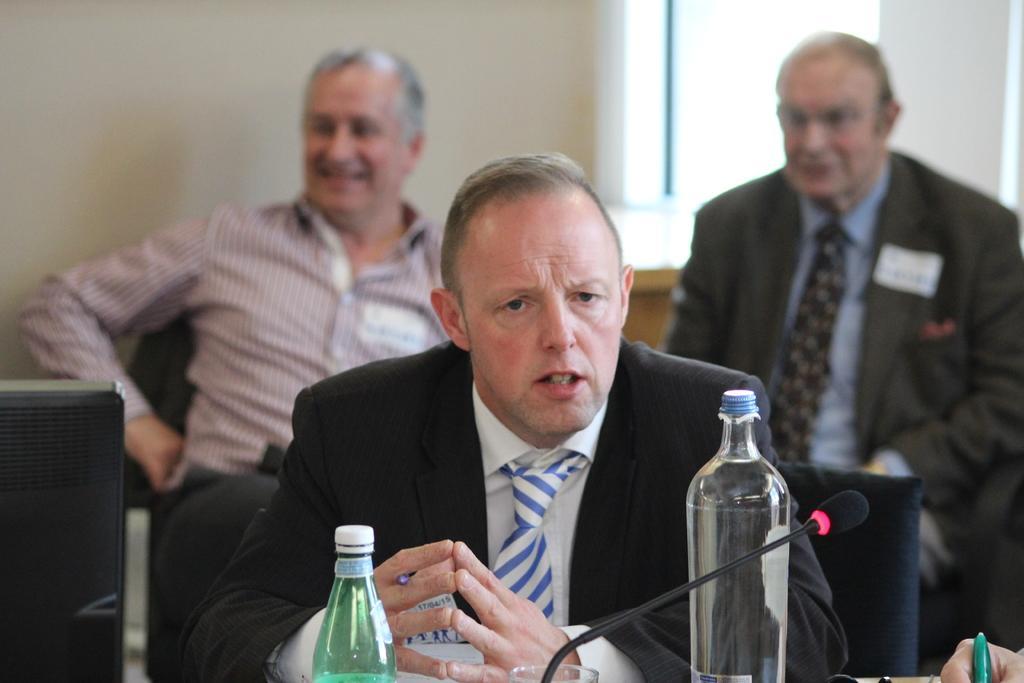In one or two sentences, can you explain what this image depicts? In this image I can see three men are sitting, here I can see few bottles and a mic. I can also see a hand of a person. 